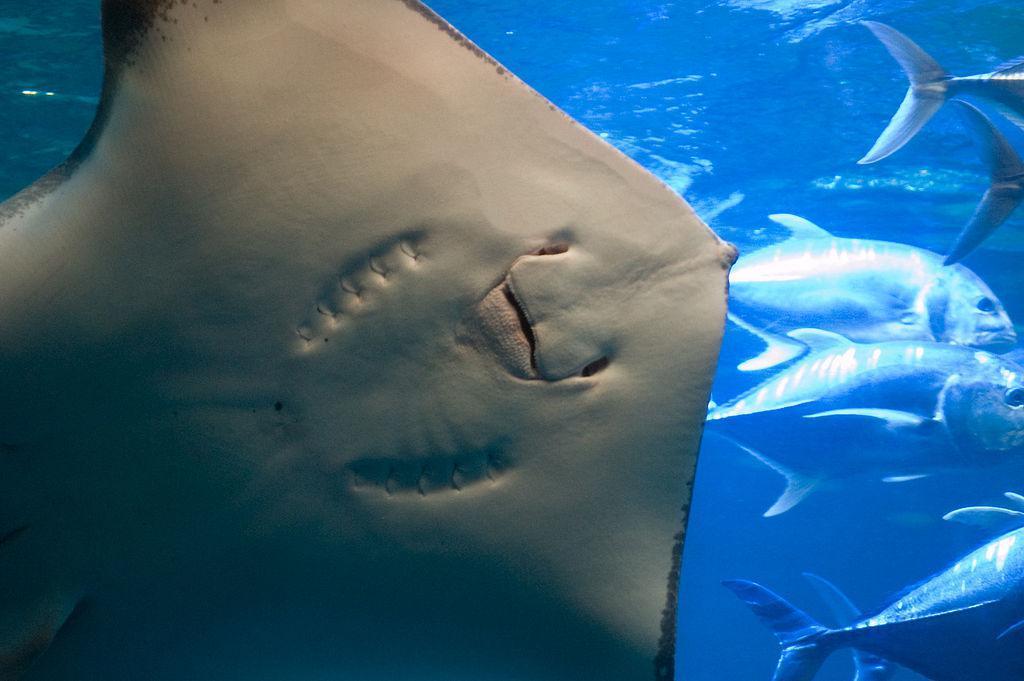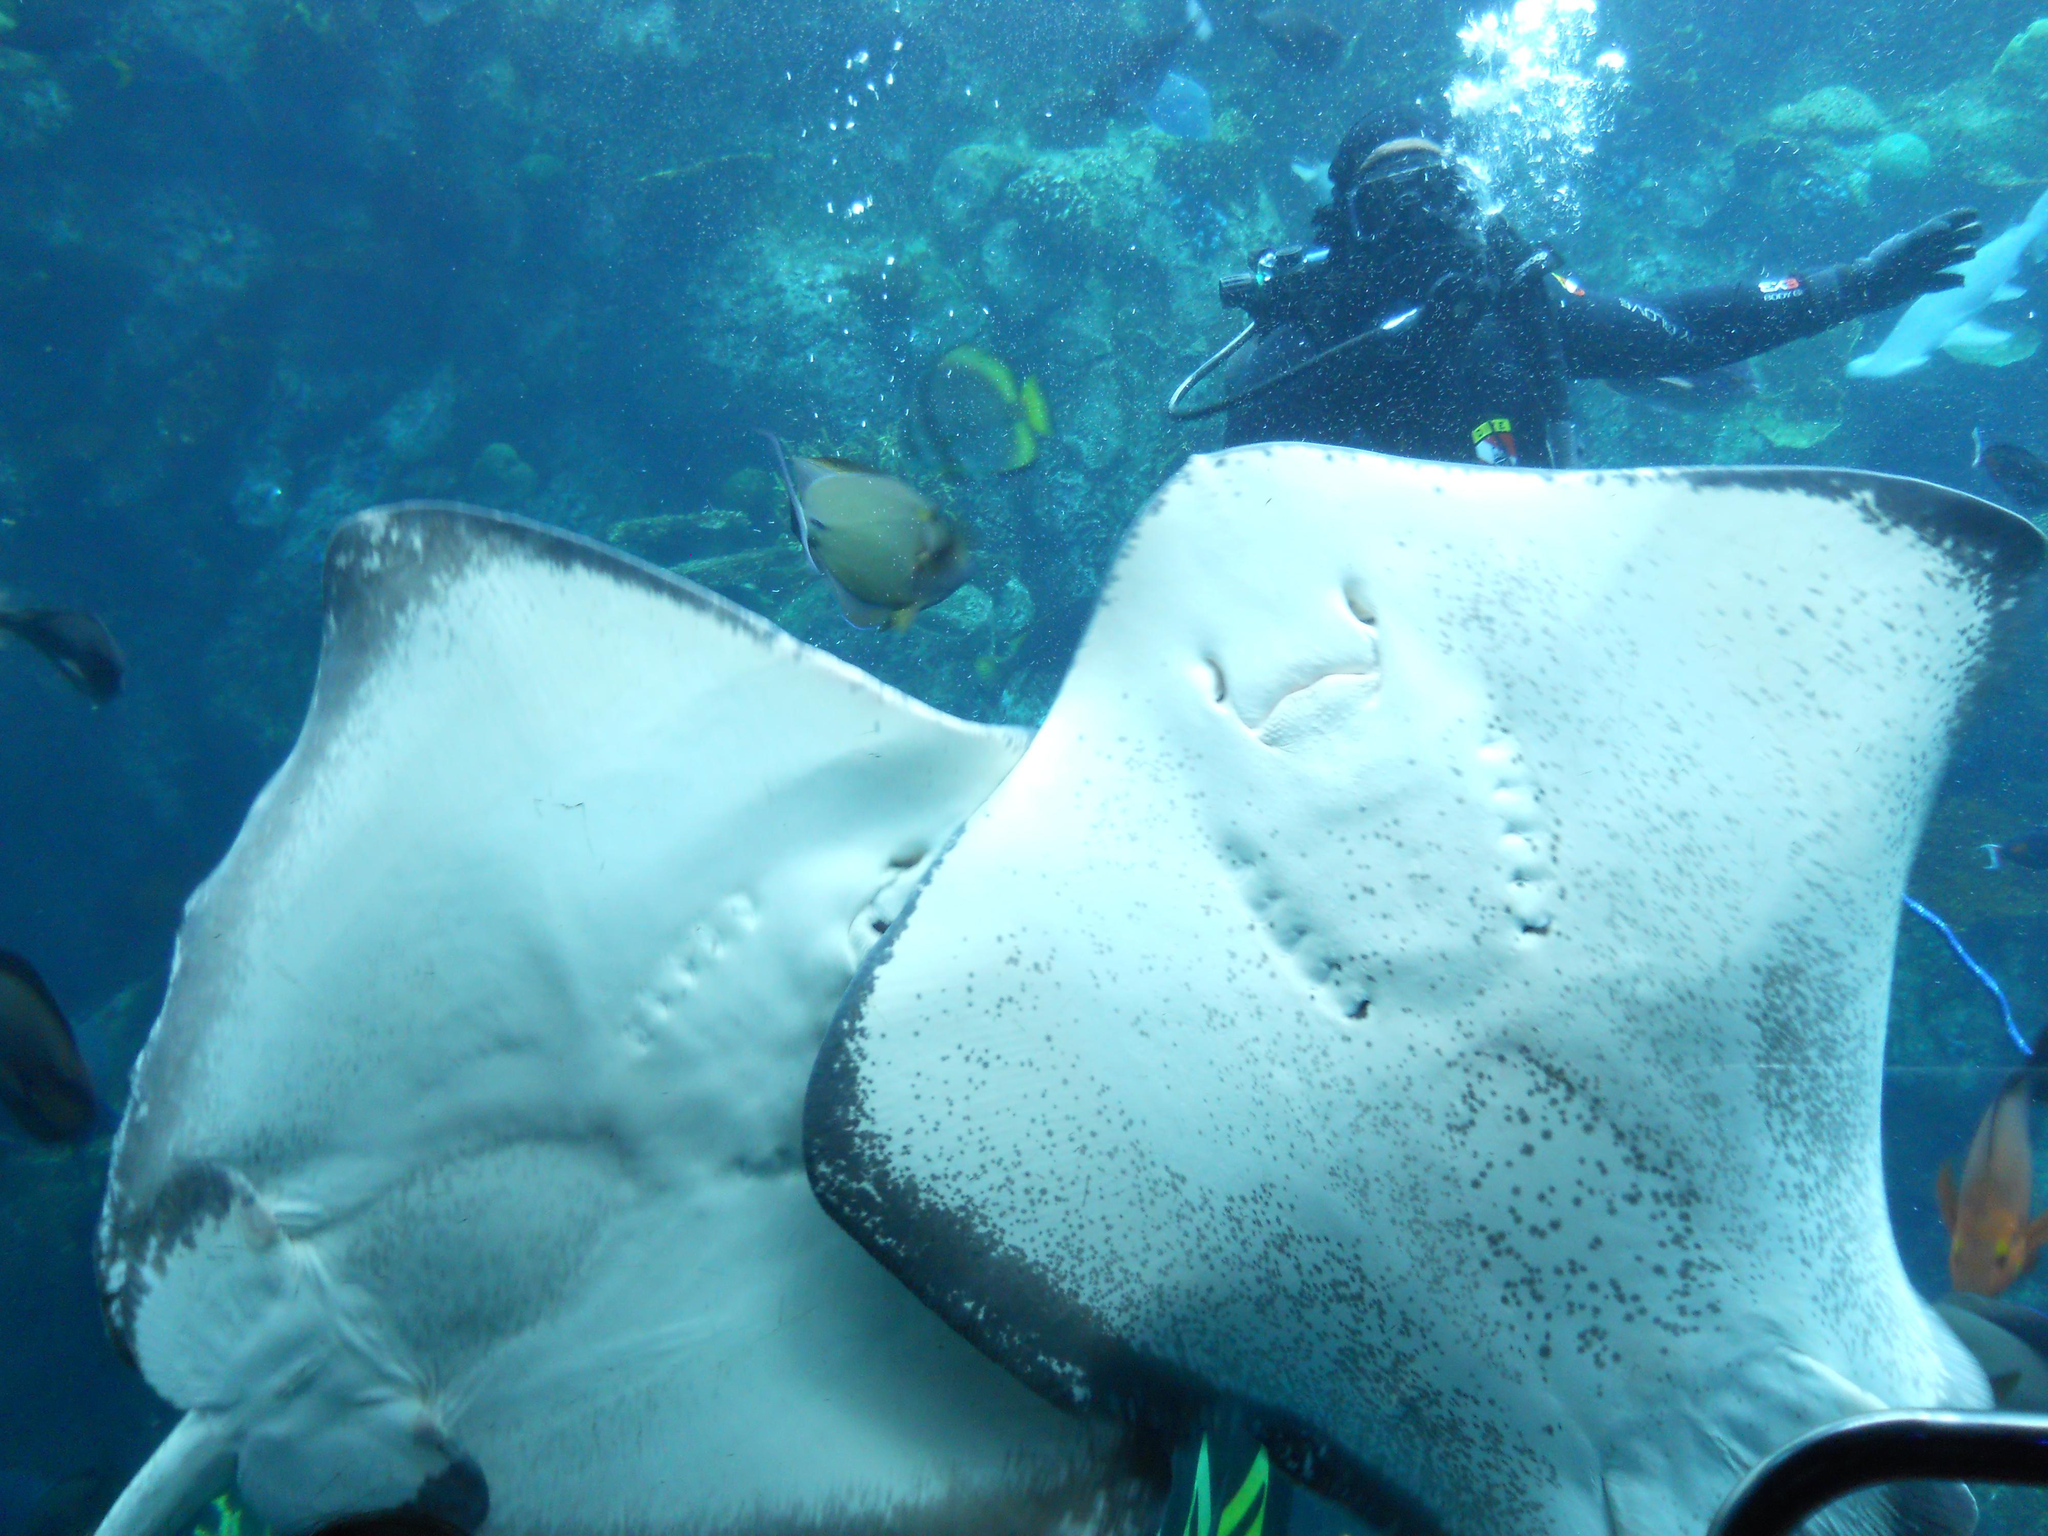The first image is the image on the left, the second image is the image on the right. For the images displayed, is the sentence "There is a close up of human hands petting the stingrays." factually correct? Answer yes or no. No. 